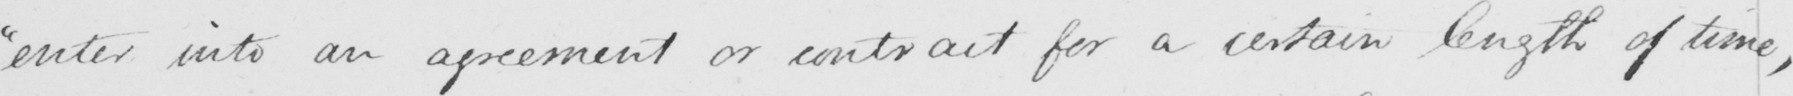Can you tell me what this handwritten text says? "enter into an agreement or contract for a certain length of time, 